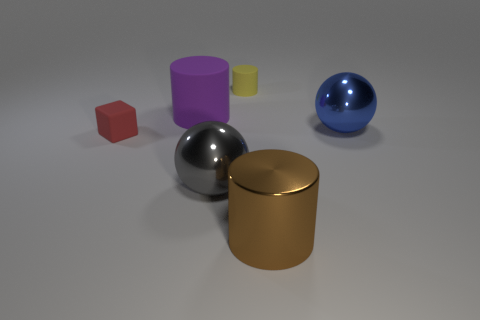How many rubber things are gray cylinders or cylinders?
Make the answer very short. 2. How many other things are the same shape as the red object?
Ensure brevity in your answer.  0. Is the number of large gray objects greater than the number of blue metallic cylinders?
Your response must be concise. Yes. There is a shiny ball that is right of the metal sphere in front of the metal ball that is right of the small yellow rubber object; what is its size?
Ensure brevity in your answer.  Large. There is a metallic object that is on the right side of the brown object; what is its size?
Ensure brevity in your answer.  Large. What number of things are either cyan rubber cylinders or things that are in front of the big gray metallic sphere?
Keep it short and to the point. 1. How many other things are there of the same size as the yellow rubber thing?
Keep it short and to the point. 1. There is another yellow thing that is the same shape as the large matte object; what is it made of?
Provide a short and direct response. Rubber. Are there more red rubber things that are in front of the tiny matte cylinder than small gray objects?
Keep it short and to the point. Yes. Are there any other things of the same color as the rubber cube?
Your answer should be compact. No. 